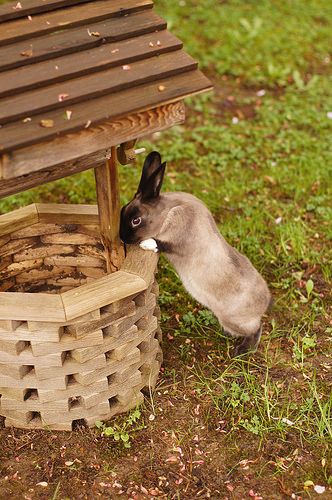<image>
Can you confirm if the grass is on the wishing well? No. The grass is not positioned on the wishing well. They may be near each other, but the grass is not supported by or resting on top of the wishing well. 